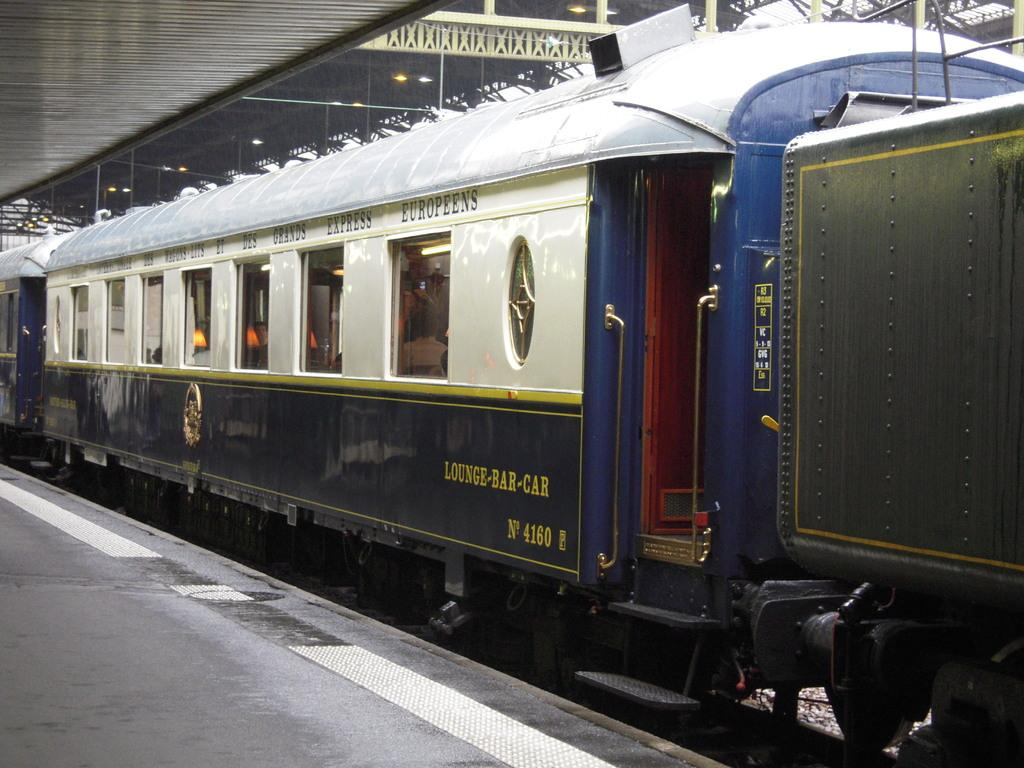<image>
Describe the image concisely. a train with the words Lounge-bar-Car written on one side. 